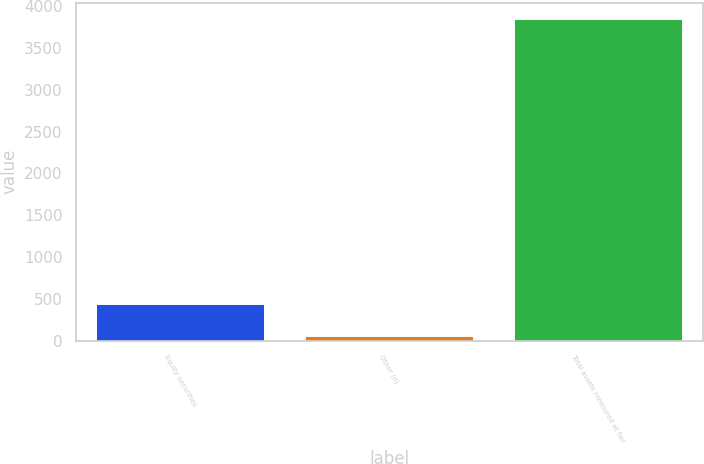<chart> <loc_0><loc_0><loc_500><loc_500><bar_chart><fcel>Equity securities<fcel>Other (d)<fcel>Total assets measured at fair<nl><fcel>432.6<fcel>53<fcel>3849<nl></chart> 